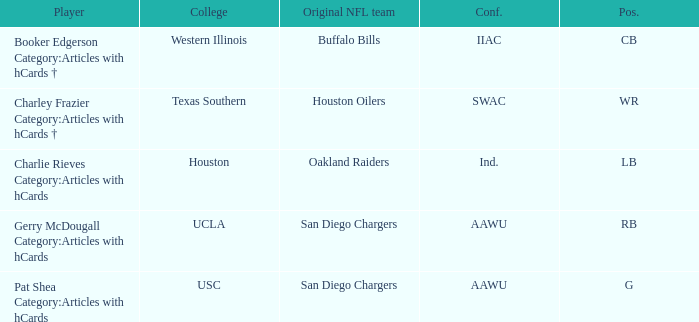What player's original team are the Buffalo Bills? Booker Edgerson Category:Articles with hCards †. 